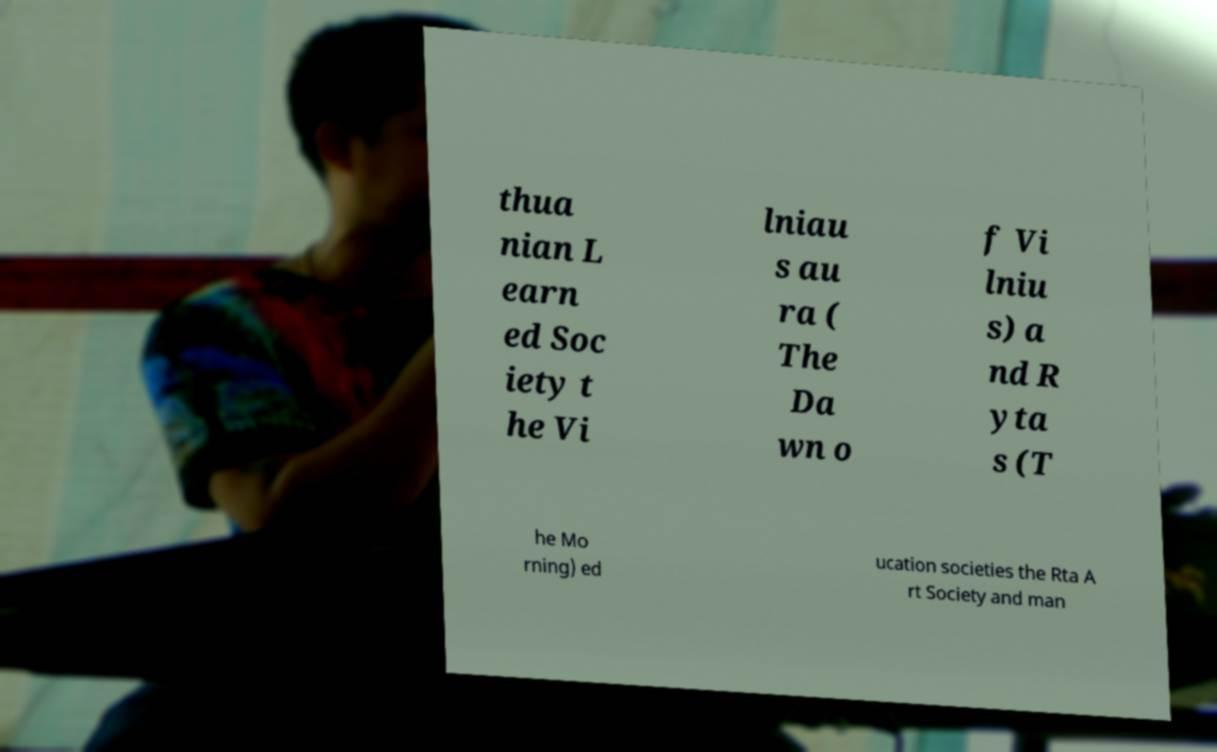I need the written content from this picture converted into text. Can you do that? thua nian L earn ed Soc iety t he Vi lniau s au ra ( The Da wn o f Vi lniu s) a nd R yta s (T he Mo rning) ed ucation societies the Rta A rt Society and man 